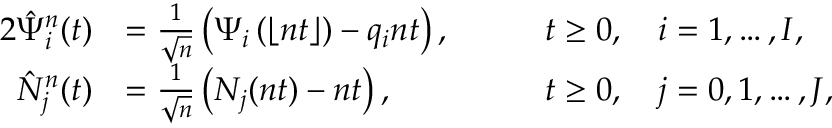<formula> <loc_0><loc_0><loc_500><loc_500>\begin{array} { r l r l } { { 2 } \hat { \Psi } _ { i } ^ { n } ( t ) } & { = \frac { 1 } { \sqrt { n } } \left ( \Psi _ { i } \left ( \lfloor n t \rfloor \right ) - q _ { i } n t \right ) , } & & { \quad t \geq 0 , \quad i = 1 , \dots , I , } \\ { \hat { N } _ { j } ^ { n } ( t ) } & { = \frac { 1 } { \sqrt { n } } \left ( N _ { j } ( n t ) - n t \right ) , } & & { \quad t \geq 0 , \quad j = 0 , 1 , \dots , J , } \end{array}</formula> 